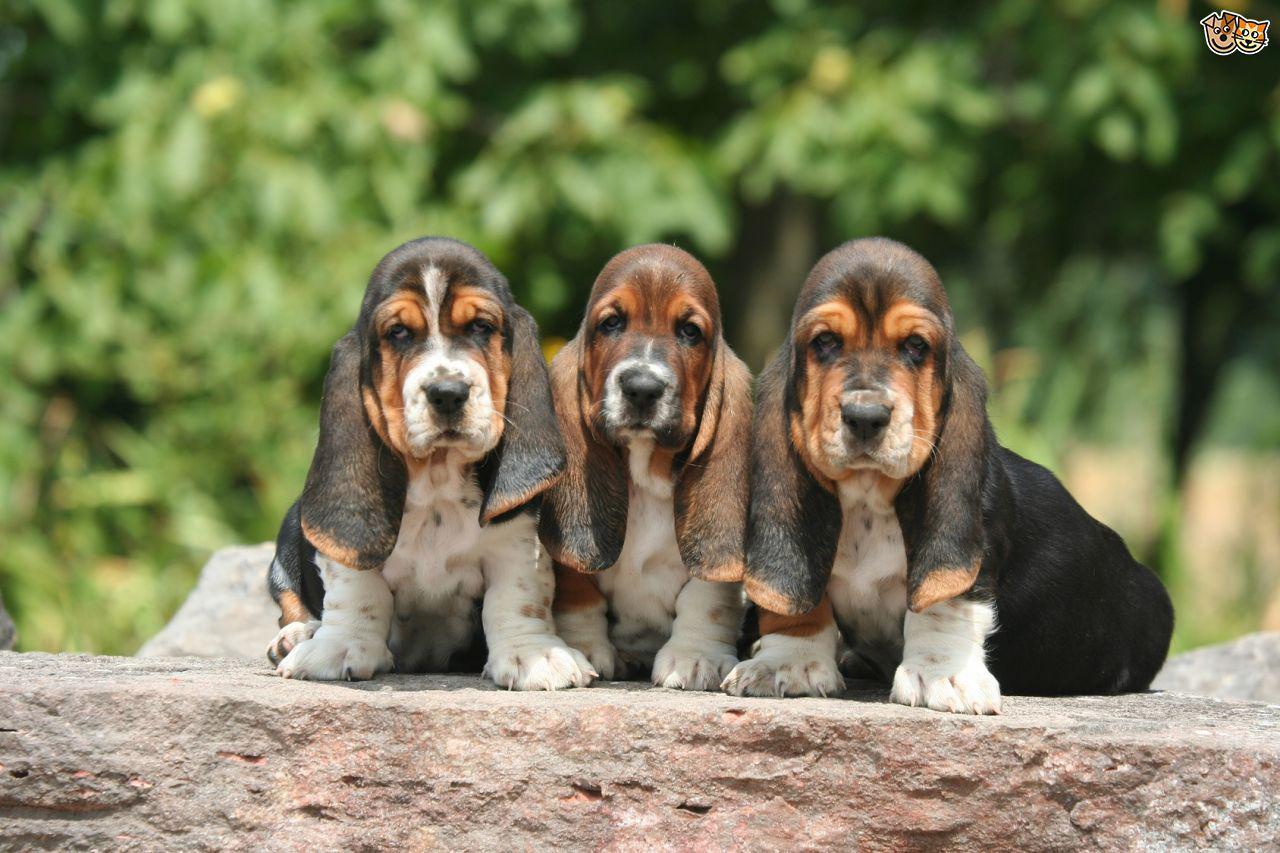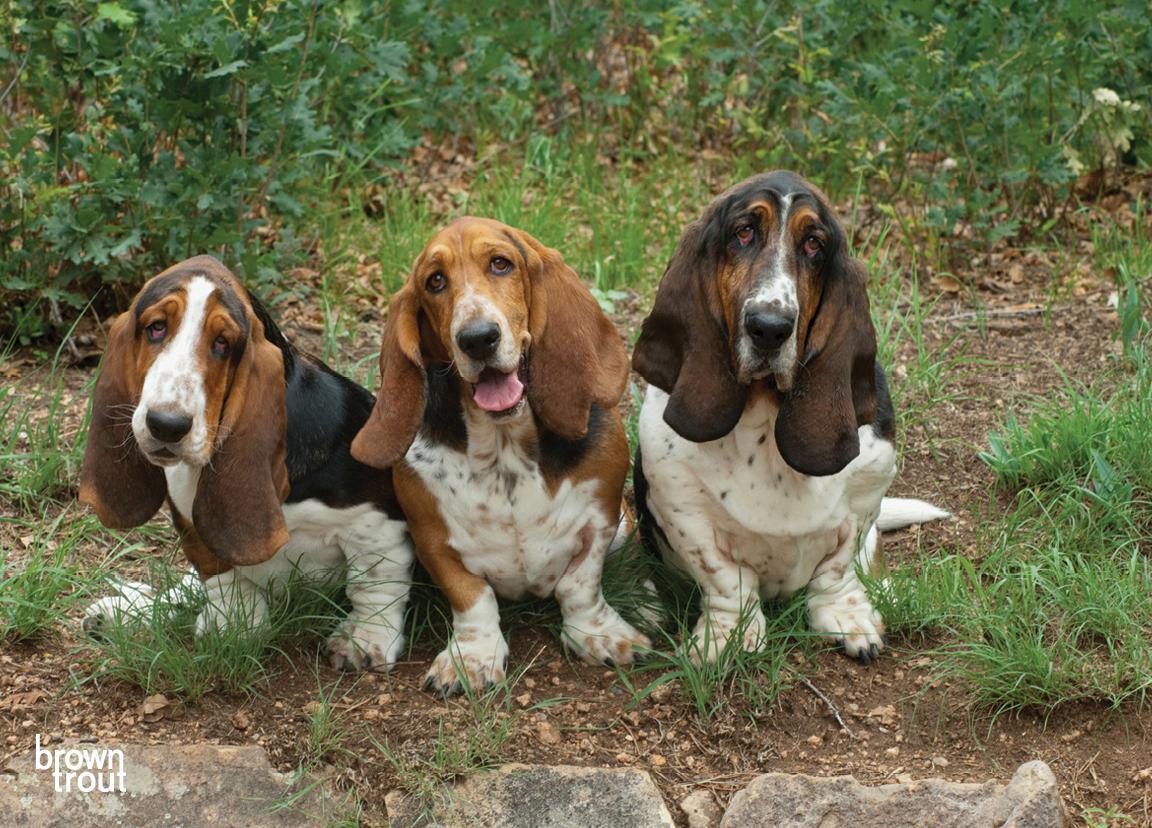The first image is the image on the left, the second image is the image on the right. Evaluate the accuracy of this statement regarding the images: "There are three dogs in the grass in the right image.". Is it true? Answer yes or no. Yes. The first image is the image on the left, the second image is the image on the right. For the images shown, is this caption "In each image there are exactly three dogs right next to each other." true? Answer yes or no. Yes. 